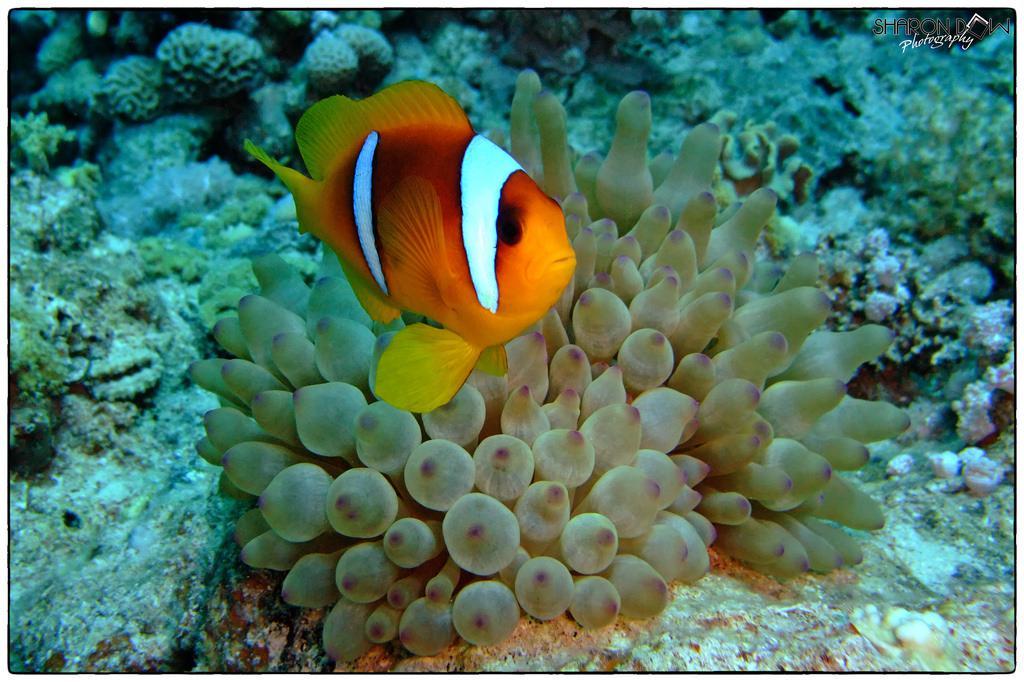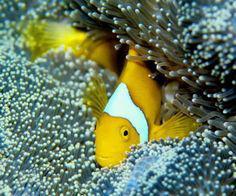The first image is the image on the left, the second image is the image on the right. Assess this claim about the two images: "There is exactly one fish in both images.". Correct or not? Answer yes or no. Yes. The first image is the image on the left, the second image is the image on the right. For the images shown, is this caption "One image shows a single orange-yellow fish with two white stripes above anemone, and no image contains fish that are not yellowish." true? Answer yes or no. Yes. 